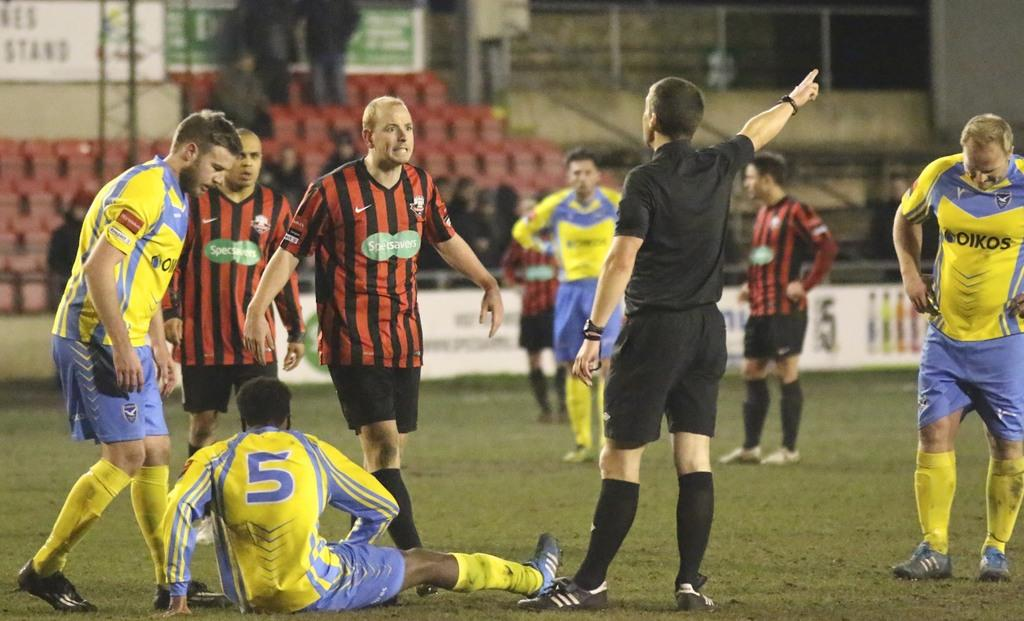Provide a one-sentence caption for the provided image. A man sits on the field at a soccer game with a large five emblazoned on his back. 